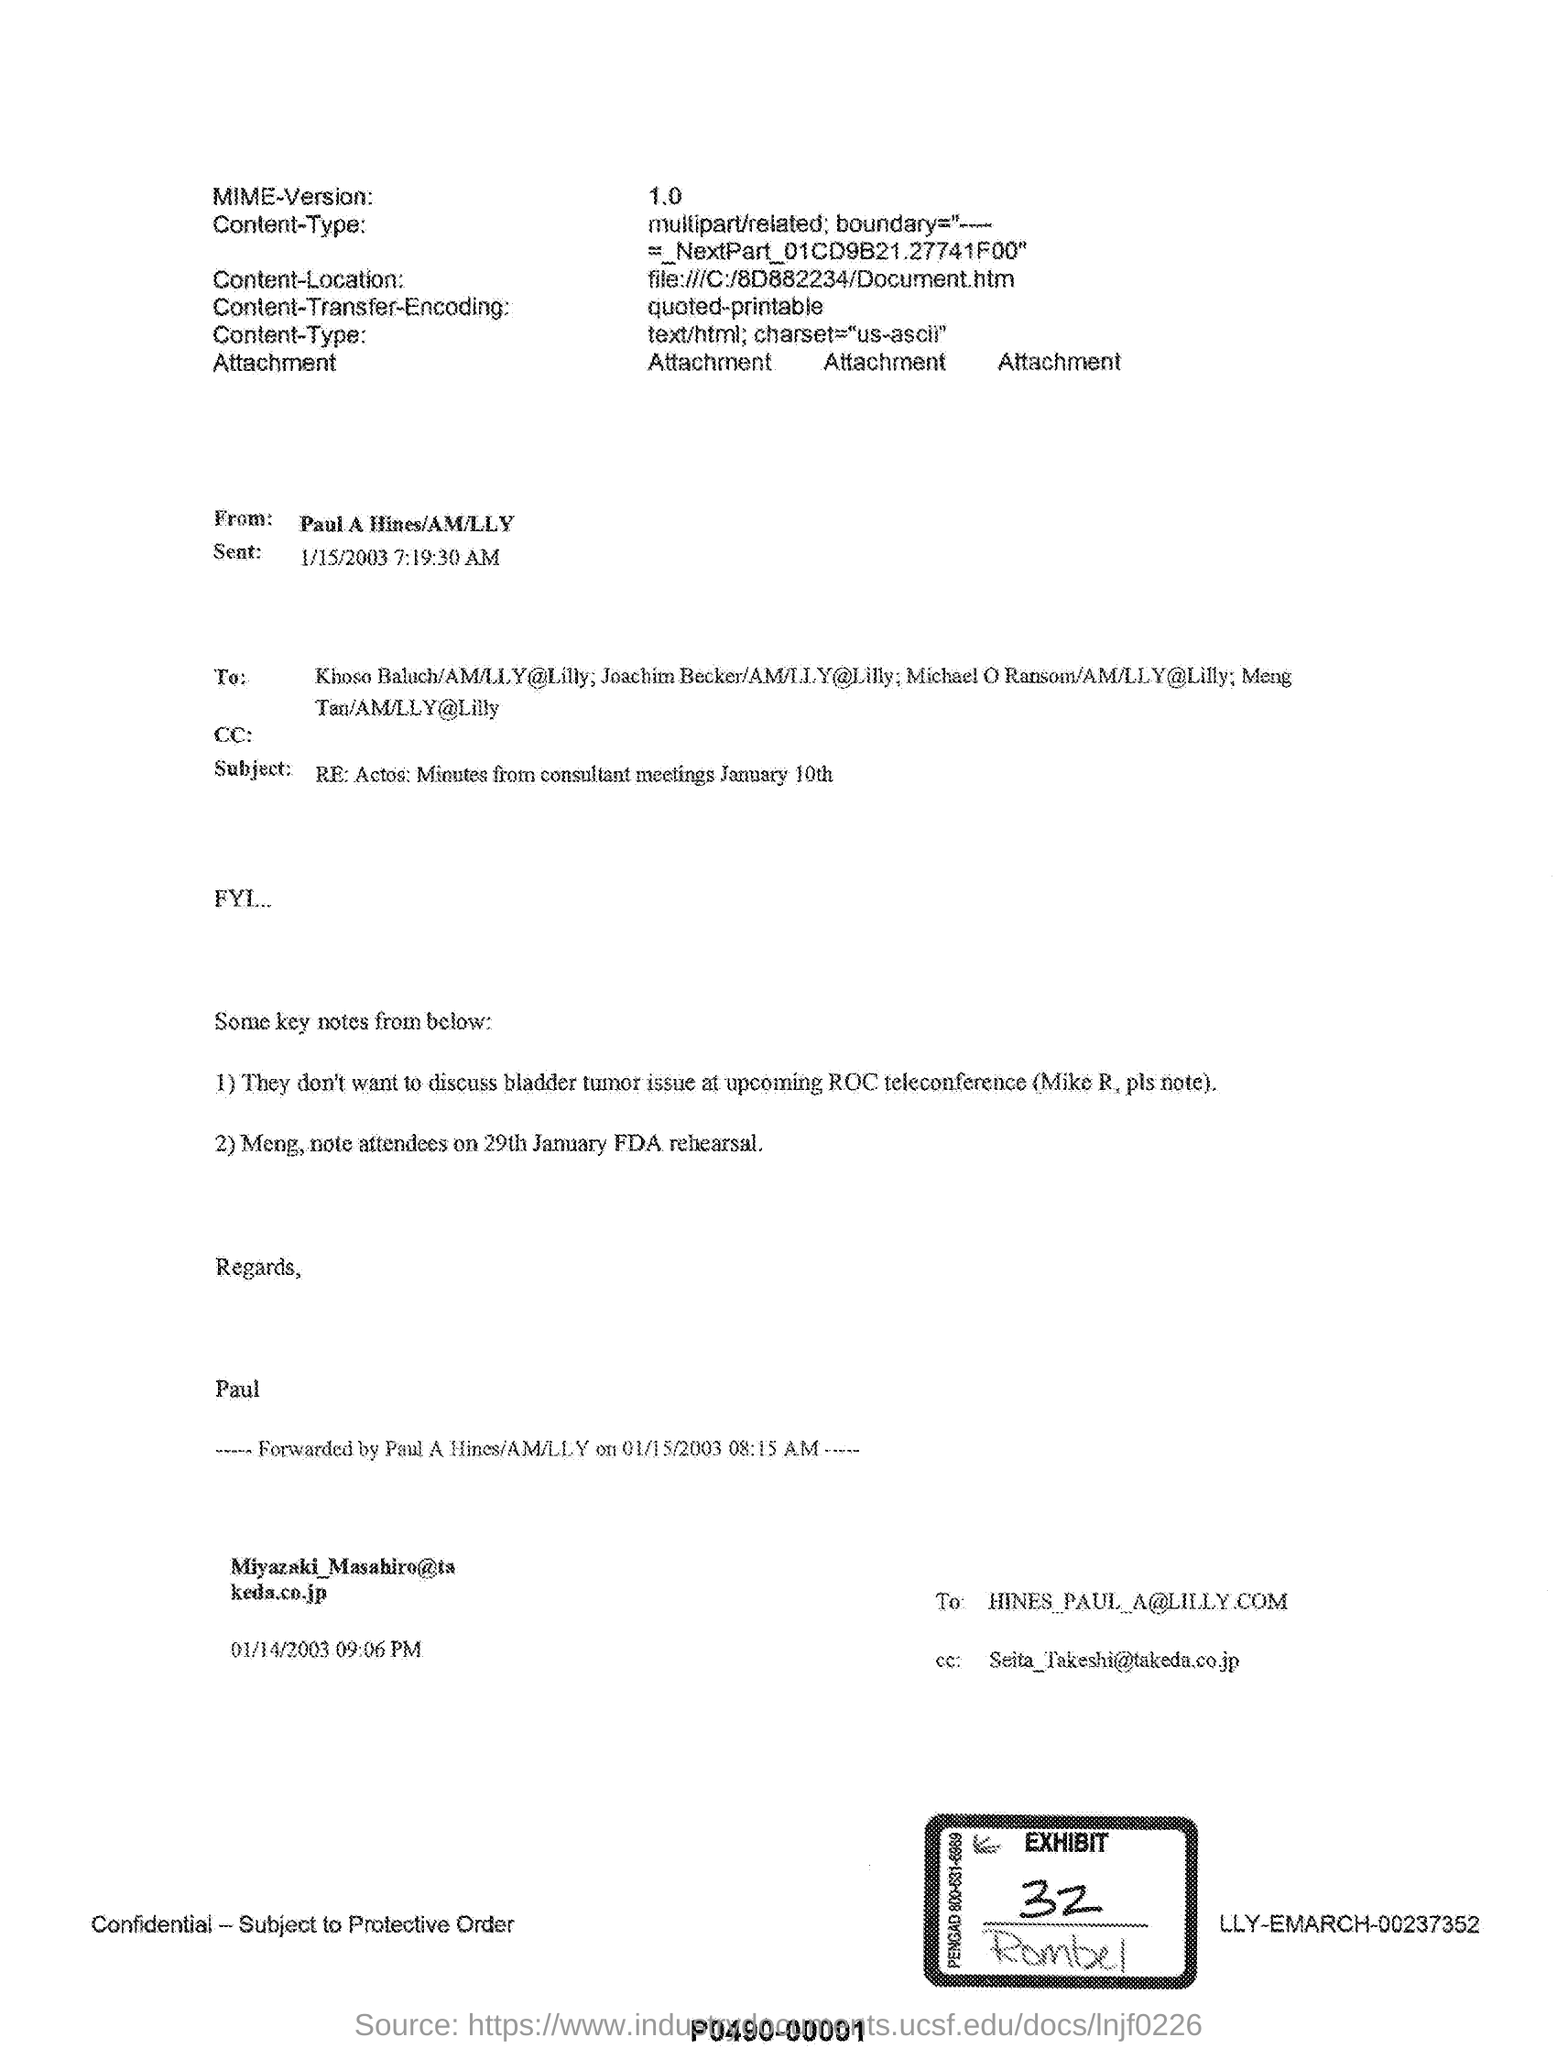What is the Exhibit No mentioned in the document?
Offer a very short reply. 32. What is the subject of the email form Paul A Hines?
Keep it short and to the point. RE: Actos: Minutes from consultant meetings January 10th. 